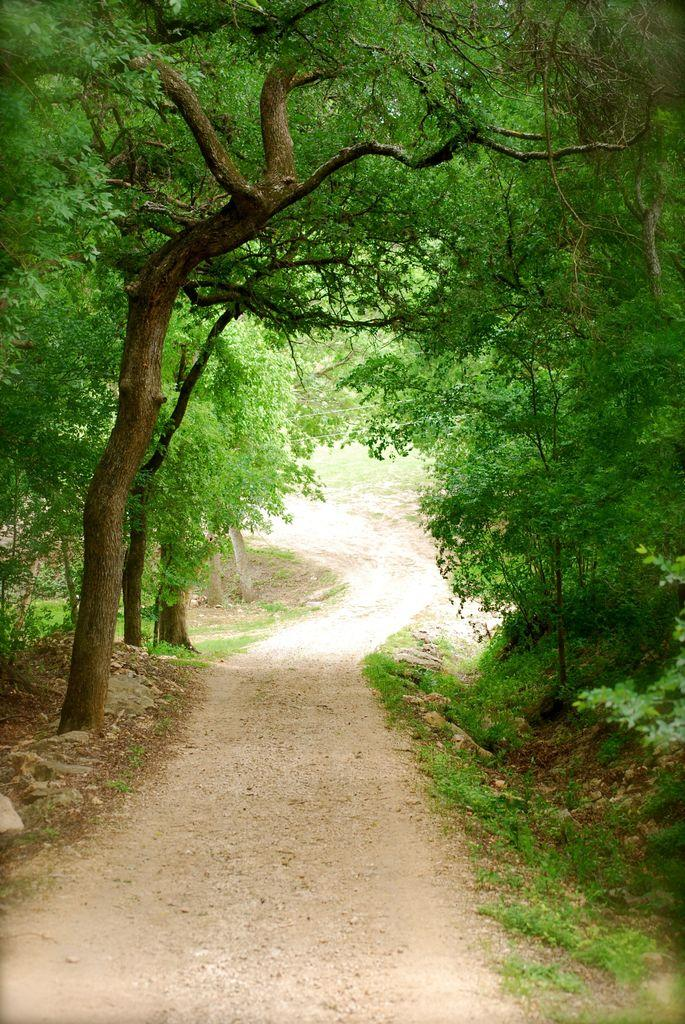What type of vegetation can be seen on the right side of the image? There are trees and plants on the right side of the image. What type of objects are present on the right side of the image? There are stones on the right side of the image. What type of vegetation can be seen on the left side of the image? There are trees and plants on the left side of the image. What type of ground cover is present on the left side of the image? There is grass on the left side of the image. What type of objects are present on the left side of the image? There are stones on the left side of the image. What can be seen in the center of the image? There is a path in the center of the image. What type of record is being played by the machine in the image? There is no record or machine present in the image. Who is the expert in the image? There is no expert or indication of expertise in the image. 